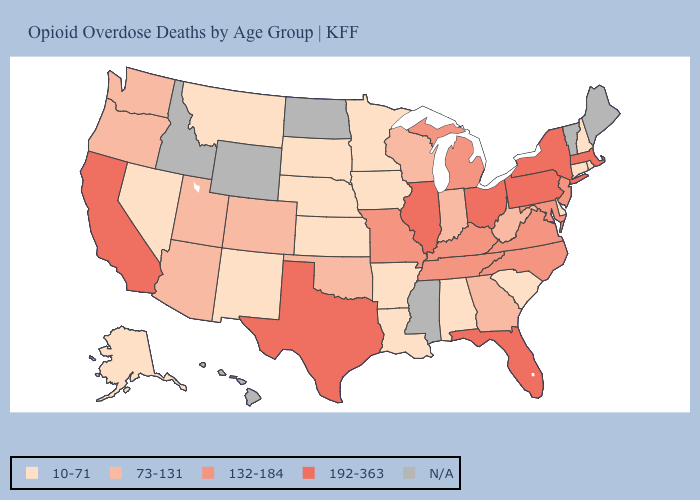Among the states that border New Mexico , which have the lowest value?
Concise answer only. Arizona, Colorado, Oklahoma, Utah. What is the value of South Dakota?
Short answer required. 10-71. Name the states that have a value in the range N/A?
Answer briefly. Hawaii, Idaho, Maine, Mississippi, North Dakota, Vermont, Wyoming. What is the value of Hawaii?
Be succinct. N/A. What is the value of Colorado?
Quick response, please. 73-131. Does the first symbol in the legend represent the smallest category?
Write a very short answer. Yes. Does the map have missing data?
Short answer required. Yes. Is the legend a continuous bar?
Short answer required. No. What is the value of Alabama?
Give a very brief answer. 10-71. What is the lowest value in the USA?
Answer briefly. 10-71. Does Indiana have the lowest value in the MidWest?
Be succinct. No. Does Ohio have the highest value in the USA?
Be succinct. Yes. 